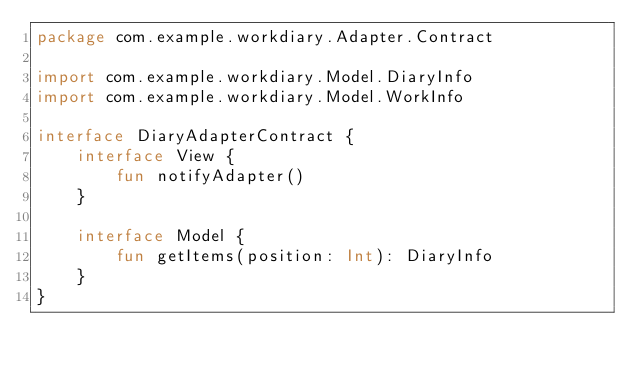Convert code to text. <code><loc_0><loc_0><loc_500><loc_500><_Kotlin_>package com.example.workdiary.Adapter.Contract

import com.example.workdiary.Model.DiaryInfo
import com.example.workdiary.Model.WorkInfo

interface DiaryAdapterContract {
    interface View {
        fun notifyAdapter()
    }

    interface Model {
        fun getItems(position: Int): DiaryInfo
    }
}</code> 